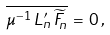Convert formula to latex. <formula><loc_0><loc_0><loc_500><loc_500>\overline { \mu ^ { - 1 } \, L _ { n } ^ { \prime } \, \widetilde { F } _ { n } } \, = \, 0 \, , \,</formula> 